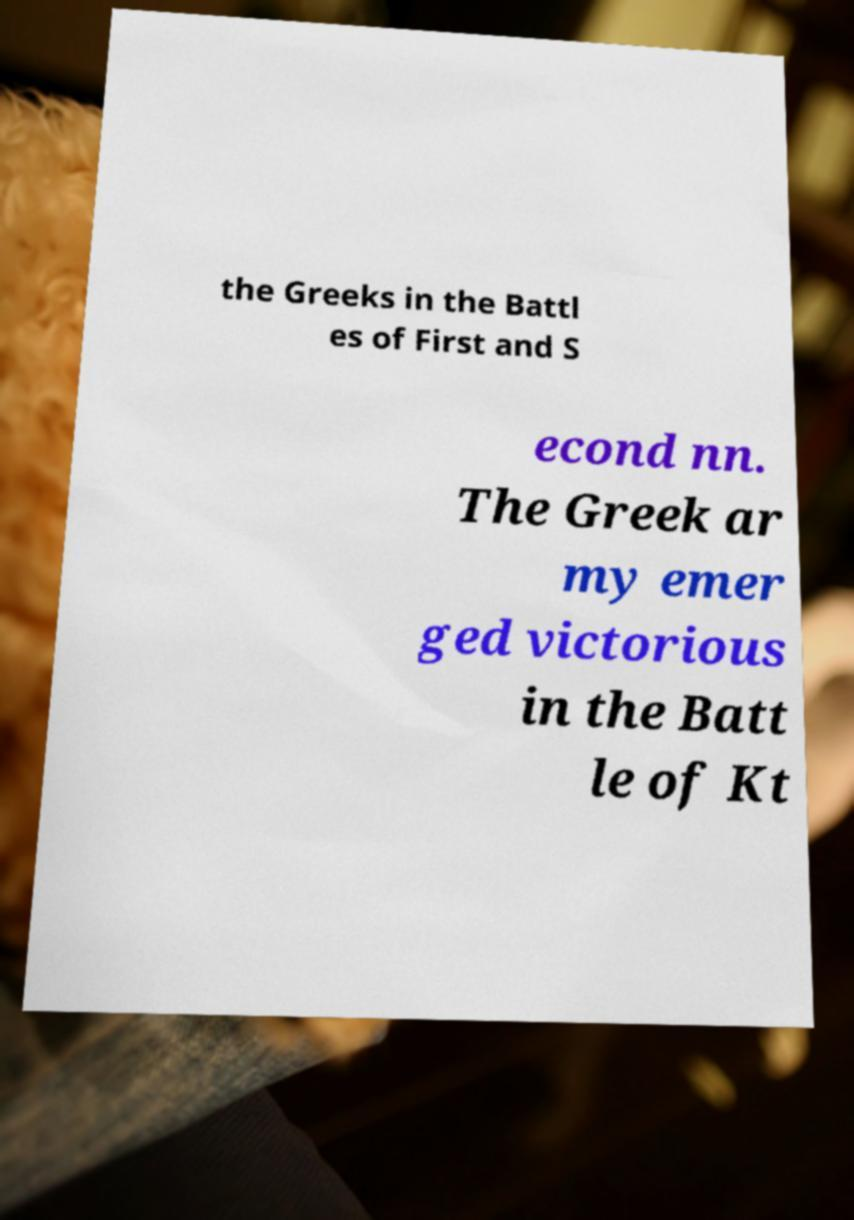Can you accurately transcribe the text from the provided image for me? the Greeks in the Battl es of First and S econd nn. The Greek ar my emer ged victorious in the Batt le of Kt 